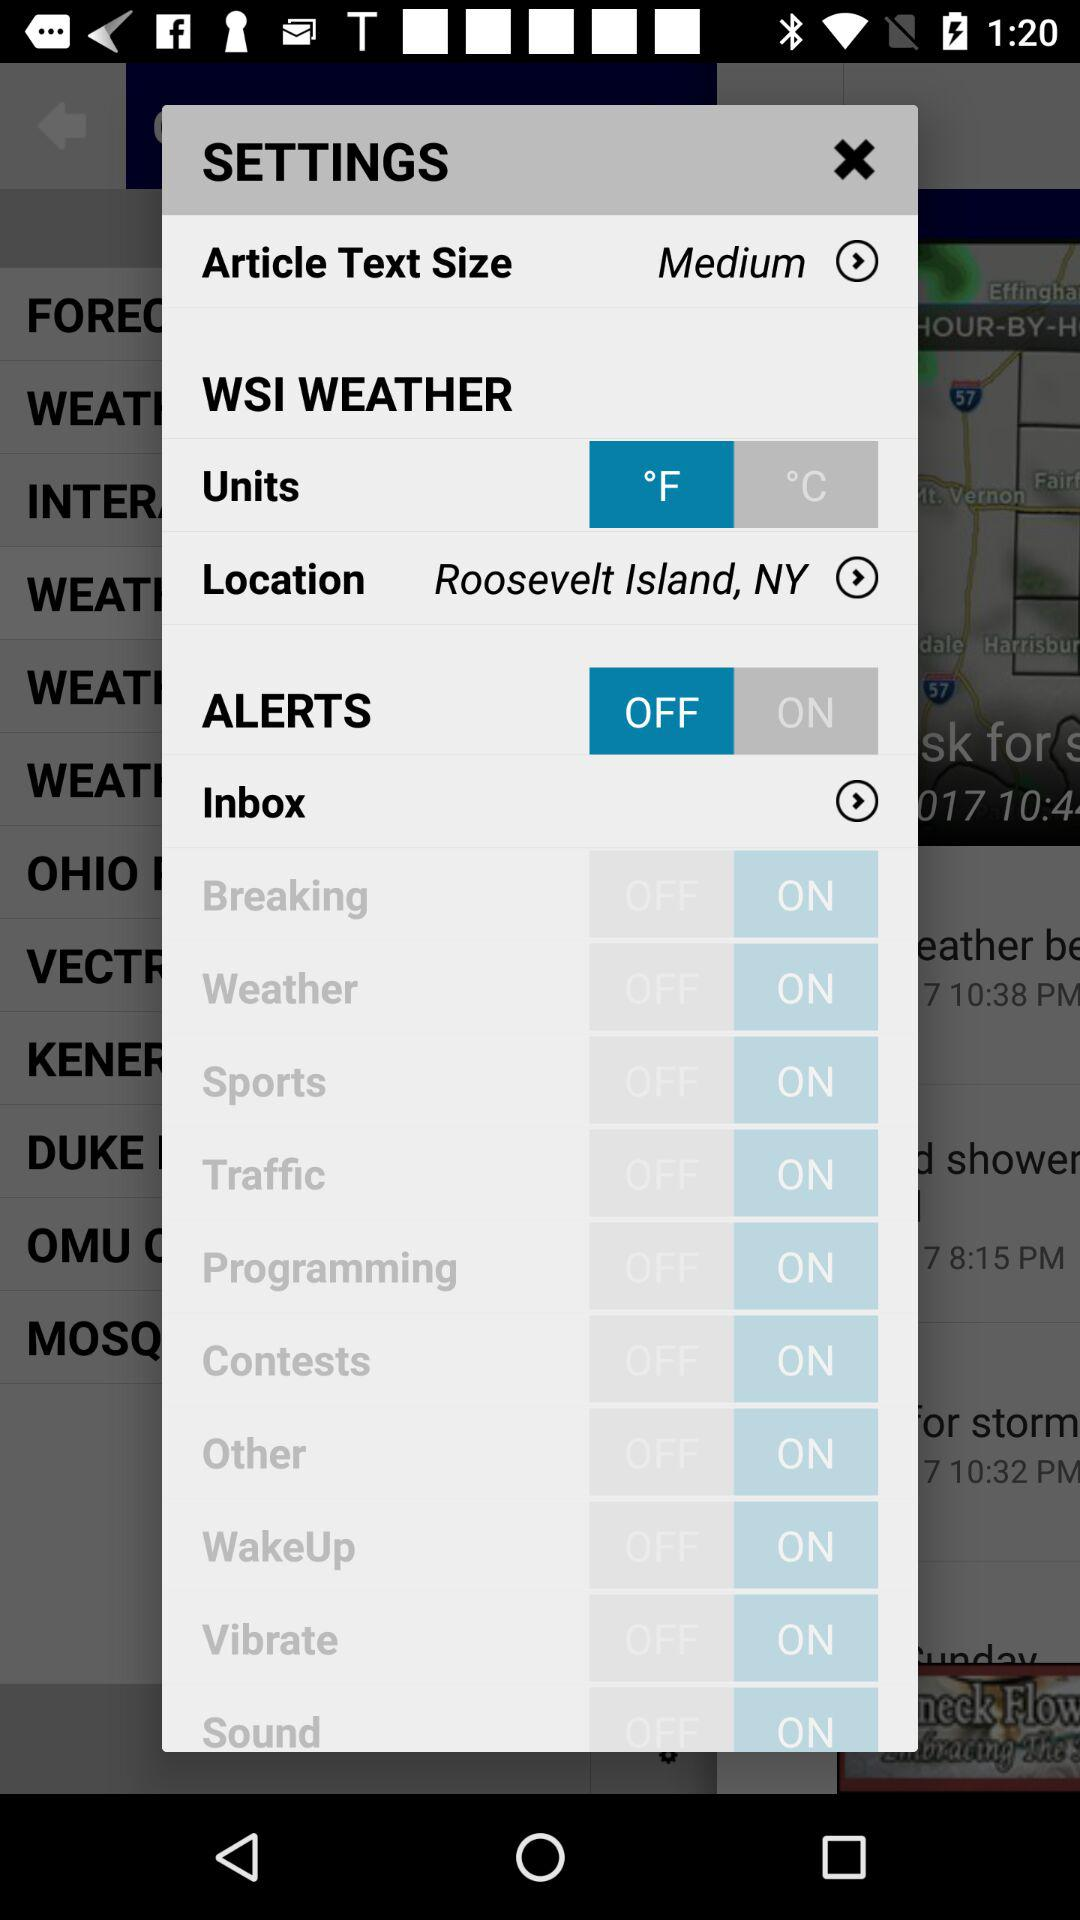What is the setting for the article text size? The setting is "Medium". 